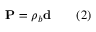<formula> <loc_0><loc_0><loc_500><loc_500>P = \rho _ { b } d \quad ( 2 )</formula> 